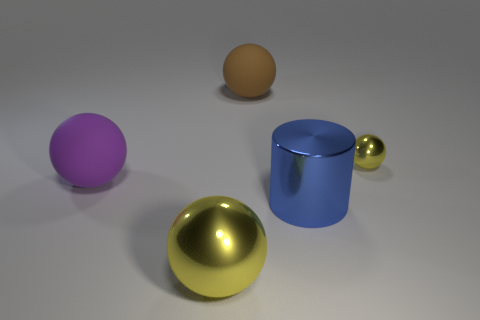There is a metal sphere that is on the left side of the tiny metal thing; is its color the same as the metal ball that is on the right side of the big brown rubber ball?
Give a very brief answer. Yes. What is the size of the yellow metallic ball on the right side of the big object behind the purple matte sphere?
Your answer should be very brief. Small. How many other objects are there of the same size as the blue cylinder?
Provide a short and direct response. 3. There is a metallic cylinder; what number of yellow shiny balls are on the right side of it?
Provide a short and direct response. 1. What size is the purple matte object?
Make the answer very short. Large. Is the big sphere behind the purple rubber thing made of the same material as the big purple object behind the metal cylinder?
Provide a succinct answer. Yes. Are there any other big metallic spheres of the same color as the big shiny sphere?
Your answer should be compact. No. There is a shiny cylinder that is the same size as the purple sphere; what is its color?
Ensure brevity in your answer.  Blue. There is a large rubber sphere that is on the right side of the big yellow object; is it the same color as the large shiny cylinder?
Your response must be concise. No. Are there any brown spheres made of the same material as the purple thing?
Give a very brief answer. Yes. 